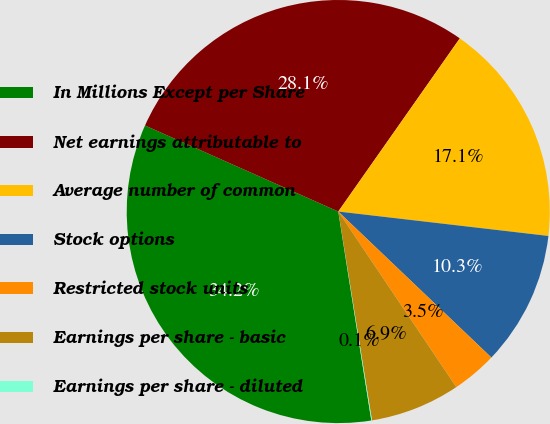Convert chart. <chart><loc_0><loc_0><loc_500><loc_500><pie_chart><fcel>In Millions Except per Share<fcel>Net earnings attributable to<fcel>Average number of common<fcel>Stock options<fcel>Restricted stock units<fcel>Earnings per share - basic<fcel>Earnings per share - diluted<nl><fcel>34.16%<fcel>28.07%<fcel>17.1%<fcel>10.28%<fcel>3.46%<fcel>6.87%<fcel>0.05%<nl></chart> 